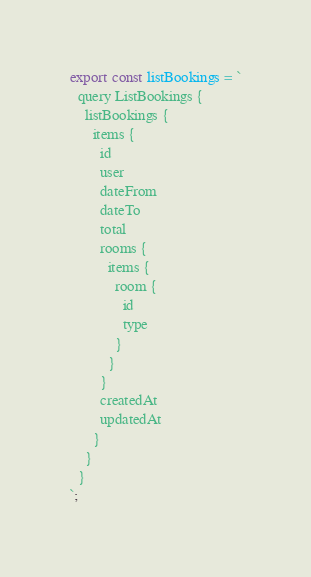<code> <loc_0><loc_0><loc_500><loc_500><_TypeScript_>export const listBookings = `
  query ListBookings {
    listBookings {
      items {
        id
        user
        dateFrom
        dateTo
        total
        rooms {
          items {
            room {
              id
              type
            }
          }
        }
        createdAt
        updatedAt
      }
    }
  }
`;</code> 